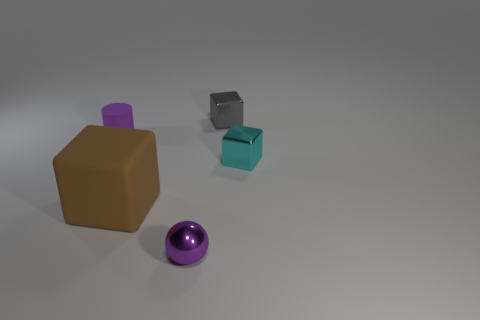Subtract all green balls. Subtract all cyan cylinders. How many balls are left? 1 Add 4 purple matte objects. How many objects exist? 9 Subtract all blocks. How many objects are left? 2 Subtract all large brown matte blocks. Subtract all shiny things. How many objects are left? 1 Add 5 tiny purple spheres. How many tiny purple spheres are left? 6 Add 2 big blocks. How many big blocks exist? 3 Subtract 0 yellow cylinders. How many objects are left? 5 